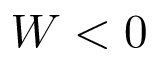Convert formula to latex. <formula><loc_0><loc_0><loc_500><loc_500>W < 0</formula> 